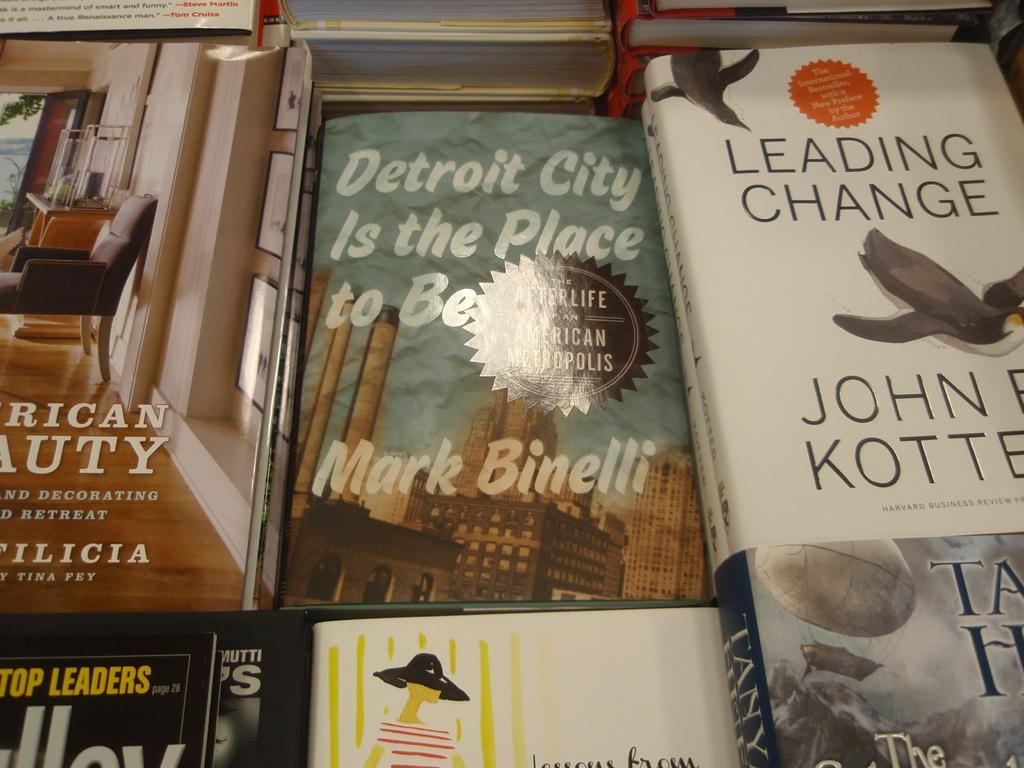<image>
Relay a brief, clear account of the picture shown. a table full of books with one of them titled 'detroit city is the place to be' 